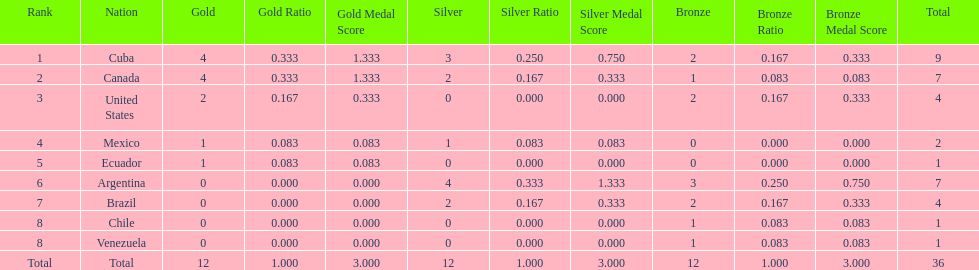How many total medals did brazil received? 4. Write the full table. {'header': ['Rank', 'Nation', 'Gold', 'Gold Ratio', 'Gold Medal Score', 'Silver', 'Silver Ratio', 'Silver Medal Score', 'Bronze', 'Bronze Ratio', 'Bronze Medal Score', 'Total'], 'rows': [['1', 'Cuba', '4', '0.333', '1.333', '3', '0.250', '0.750', '2', '0.167', '0.333', '9'], ['2', 'Canada', '4', '0.333', '1.333', '2', '0.167', '0.333', '1', '0.083', '0.083', '7'], ['3', 'United States', '2', '0.167', '0.333', '0', '0.000', '0.000', '2', '0.167', '0.333', '4'], ['4', 'Mexico', '1', '0.083', '0.083', '1', '0.083', '0.083', '0', '0.000', '0.000', '2'], ['5', 'Ecuador', '1', '0.083', '0.083', '0', '0.000', '0.000', '0', '0.000', '0.000', '1'], ['6', 'Argentina', '0', '0.000', '0.000', '4', '0.333', '1.333', '3', '0.250', '0.750', '7'], ['7', 'Brazil', '0', '0.000', '0.000', '2', '0.167', '0.333', '2', '0.167', '0.333', '4'], ['8', 'Chile', '0', '0.000', '0.000', '0', '0.000', '0.000', '1', '0.083', '0.083', '1'], ['8', 'Venezuela', '0', '0.000', '0.000', '0', '0.000', '0.000', '1', '0.083', '0.083', '1'], ['Total', 'Total', '12', '1.000', '3.000', '12', '1.000', '3.000', '12', '1.000', '3.000', '36']]} 